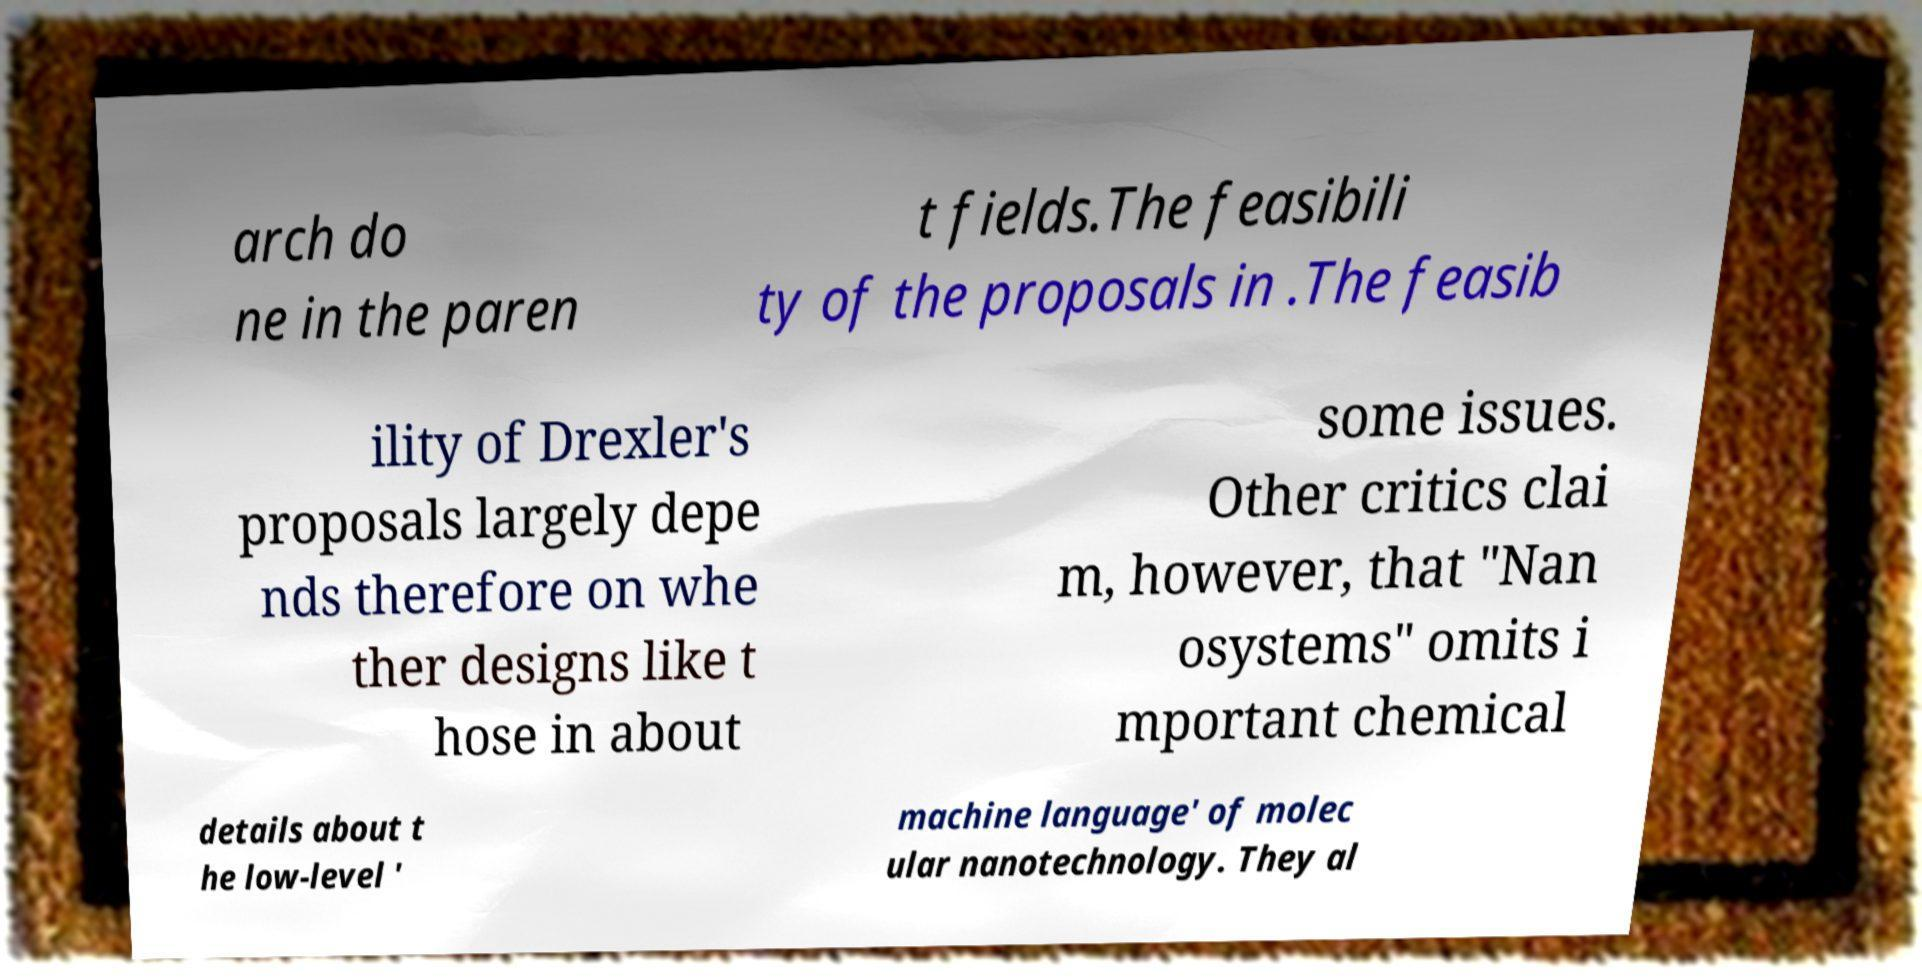Could you extract and type out the text from this image? arch do ne in the paren t fields.The feasibili ty of the proposals in .The feasib ility of Drexler's proposals largely depe nds therefore on whe ther designs like t hose in about some issues. Other critics clai m, however, that "Nan osystems" omits i mportant chemical details about t he low-level ' machine language' of molec ular nanotechnology. They al 